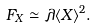Convert formula to latex. <formula><loc_0><loc_0><loc_500><loc_500>F _ { X } \simeq \lambda \langle X \rangle ^ { 2 } .</formula> 